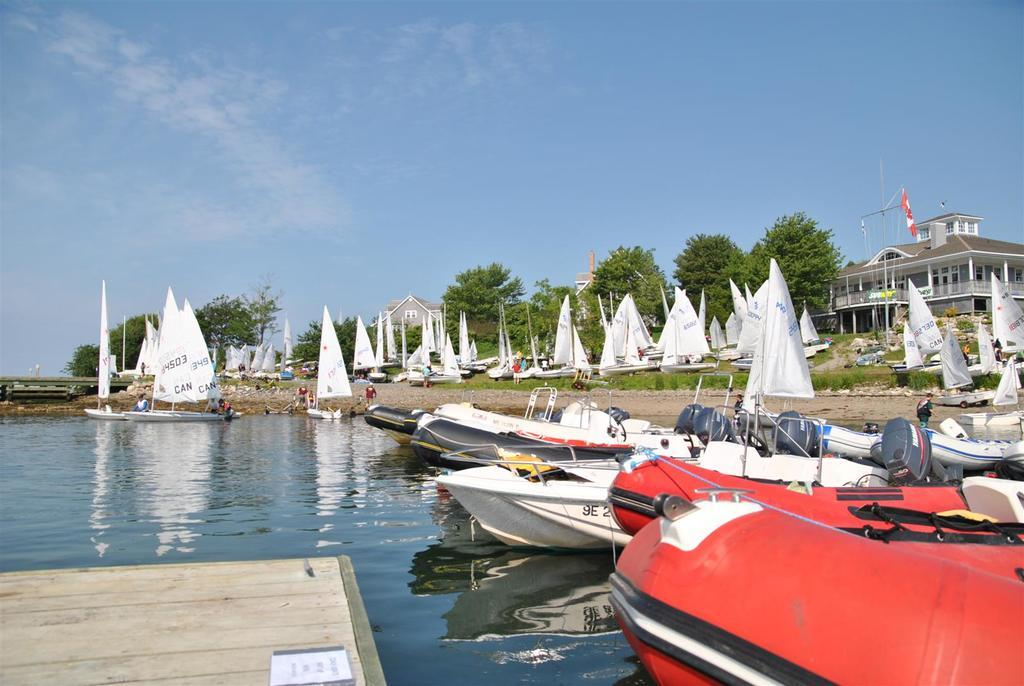What type of vehicles can be seen in the image? There are boats in the image. What decorative or symbolic items are present in the image? There are flags in the image. What type of terrain is visible in the image? There is grass in the image. What natural element is visible in the image? There is water visible in the image. What structures can be seen in the background of the image? There is a building in the background of the image. What type of vegetation is visible in the background of the image? There are trees in the background of the image. What part of the natural environment is visible in the background of the image? The sky is visible in the background of the image. Can you tell me how many deer are grazing in the grass in the image? There are no deer present in the image; it features boats, flags, grass, water, a building, trees, and the sky. What type of butter is being used to spread on the boats in the image? There is no butter present in the image, and the boats are not being used for food consumption. 